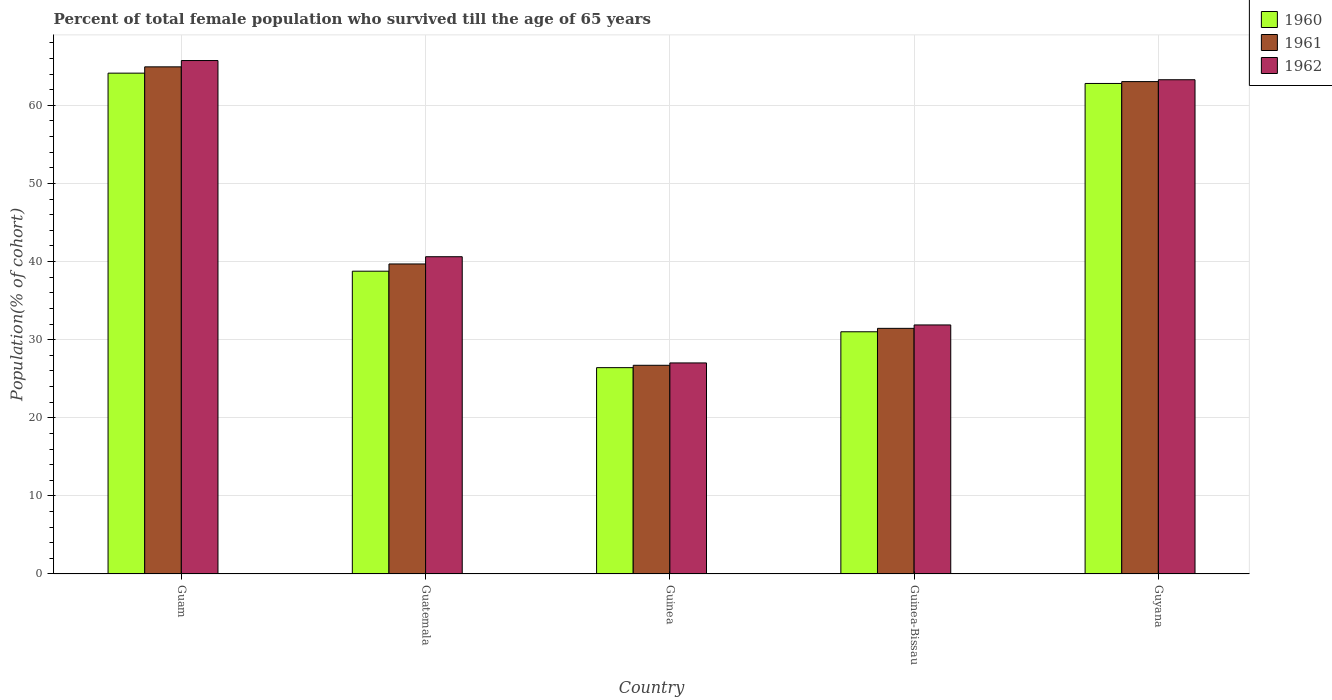How many different coloured bars are there?
Offer a terse response. 3. How many groups of bars are there?
Your answer should be compact. 5. How many bars are there on the 5th tick from the left?
Make the answer very short. 3. What is the label of the 3rd group of bars from the left?
Provide a succinct answer. Guinea. What is the percentage of total female population who survived till the age of 65 years in 1961 in Guam?
Your answer should be compact. 64.93. Across all countries, what is the maximum percentage of total female population who survived till the age of 65 years in 1961?
Your answer should be very brief. 64.93. Across all countries, what is the minimum percentage of total female population who survived till the age of 65 years in 1961?
Offer a terse response. 26.72. In which country was the percentage of total female population who survived till the age of 65 years in 1962 maximum?
Your answer should be very brief. Guam. In which country was the percentage of total female population who survived till the age of 65 years in 1961 minimum?
Provide a succinct answer. Guinea. What is the total percentage of total female population who survived till the age of 65 years in 1962 in the graph?
Your answer should be compact. 228.53. What is the difference between the percentage of total female population who survived till the age of 65 years in 1962 in Guam and that in Guinea?
Offer a very short reply. 38.71. What is the difference between the percentage of total female population who survived till the age of 65 years in 1961 in Guinea-Bissau and the percentage of total female population who survived till the age of 65 years in 1962 in Guam?
Your answer should be very brief. -34.29. What is the average percentage of total female population who survived till the age of 65 years in 1960 per country?
Keep it short and to the point. 44.62. What is the difference between the percentage of total female population who survived till the age of 65 years of/in 1961 and percentage of total female population who survived till the age of 65 years of/in 1962 in Guam?
Ensure brevity in your answer.  -0.81. In how many countries, is the percentage of total female population who survived till the age of 65 years in 1960 greater than 34 %?
Keep it short and to the point. 3. What is the ratio of the percentage of total female population who survived till the age of 65 years in 1960 in Guam to that in Guatemala?
Ensure brevity in your answer.  1.65. Is the percentage of total female population who survived till the age of 65 years in 1961 in Guatemala less than that in Guyana?
Keep it short and to the point. Yes. Is the difference between the percentage of total female population who survived till the age of 65 years in 1961 in Guinea-Bissau and Guyana greater than the difference between the percentage of total female population who survived till the age of 65 years in 1962 in Guinea-Bissau and Guyana?
Your response must be concise. No. What is the difference between the highest and the second highest percentage of total female population who survived till the age of 65 years in 1961?
Give a very brief answer. 25.24. What is the difference between the highest and the lowest percentage of total female population who survived till the age of 65 years in 1962?
Your answer should be very brief. 38.71. In how many countries, is the percentage of total female population who survived till the age of 65 years in 1960 greater than the average percentage of total female population who survived till the age of 65 years in 1960 taken over all countries?
Offer a terse response. 2. Is the sum of the percentage of total female population who survived till the age of 65 years in 1960 in Guam and Guatemala greater than the maximum percentage of total female population who survived till the age of 65 years in 1962 across all countries?
Your answer should be compact. Yes. What does the 1st bar from the left in Guatemala represents?
Make the answer very short. 1960. What does the 1st bar from the right in Guinea represents?
Offer a very short reply. 1962. Is it the case that in every country, the sum of the percentage of total female population who survived till the age of 65 years in 1960 and percentage of total female population who survived till the age of 65 years in 1961 is greater than the percentage of total female population who survived till the age of 65 years in 1962?
Keep it short and to the point. Yes. Are all the bars in the graph horizontal?
Ensure brevity in your answer.  No. Are the values on the major ticks of Y-axis written in scientific E-notation?
Give a very brief answer. No. Does the graph contain any zero values?
Your response must be concise. No. Does the graph contain grids?
Make the answer very short. Yes. How many legend labels are there?
Your answer should be compact. 3. What is the title of the graph?
Your answer should be very brief. Percent of total female population who survived till the age of 65 years. What is the label or title of the Y-axis?
Offer a terse response. Population(% of cohort). What is the Population(% of cohort) of 1960 in Guam?
Provide a short and direct response. 64.12. What is the Population(% of cohort) of 1961 in Guam?
Offer a terse response. 64.93. What is the Population(% of cohort) of 1962 in Guam?
Give a very brief answer. 65.73. What is the Population(% of cohort) in 1960 in Guatemala?
Provide a short and direct response. 38.76. What is the Population(% of cohort) in 1961 in Guatemala?
Ensure brevity in your answer.  39.69. What is the Population(% of cohort) of 1962 in Guatemala?
Keep it short and to the point. 40.62. What is the Population(% of cohort) of 1960 in Guinea?
Ensure brevity in your answer.  26.42. What is the Population(% of cohort) of 1961 in Guinea?
Make the answer very short. 26.72. What is the Population(% of cohort) in 1962 in Guinea?
Make the answer very short. 27.02. What is the Population(% of cohort) of 1960 in Guinea-Bissau?
Provide a short and direct response. 31.01. What is the Population(% of cohort) in 1961 in Guinea-Bissau?
Your answer should be compact. 31.45. What is the Population(% of cohort) of 1962 in Guinea-Bissau?
Your response must be concise. 31.88. What is the Population(% of cohort) in 1960 in Guyana?
Keep it short and to the point. 62.8. What is the Population(% of cohort) in 1961 in Guyana?
Provide a succinct answer. 63.04. What is the Population(% of cohort) of 1962 in Guyana?
Provide a short and direct response. 63.28. Across all countries, what is the maximum Population(% of cohort) of 1960?
Give a very brief answer. 64.12. Across all countries, what is the maximum Population(% of cohort) in 1961?
Provide a succinct answer. 64.93. Across all countries, what is the maximum Population(% of cohort) of 1962?
Make the answer very short. 65.73. Across all countries, what is the minimum Population(% of cohort) in 1960?
Keep it short and to the point. 26.42. Across all countries, what is the minimum Population(% of cohort) in 1961?
Your answer should be compact. 26.72. Across all countries, what is the minimum Population(% of cohort) in 1962?
Ensure brevity in your answer.  27.02. What is the total Population(% of cohort) in 1960 in the graph?
Make the answer very short. 223.1. What is the total Population(% of cohort) in 1961 in the graph?
Offer a terse response. 225.82. What is the total Population(% of cohort) of 1962 in the graph?
Your response must be concise. 228.53. What is the difference between the Population(% of cohort) of 1960 in Guam and that in Guatemala?
Provide a short and direct response. 25.36. What is the difference between the Population(% of cohort) in 1961 in Guam and that in Guatemala?
Make the answer very short. 25.24. What is the difference between the Population(% of cohort) of 1962 in Guam and that in Guatemala?
Offer a very short reply. 25.12. What is the difference between the Population(% of cohort) in 1960 in Guam and that in Guinea?
Your answer should be very brief. 37.7. What is the difference between the Population(% of cohort) in 1961 in Guam and that in Guinea?
Offer a very short reply. 38.21. What is the difference between the Population(% of cohort) of 1962 in Guam and that in Guinea?
Your answer should be very brief. 38.71. What is the difference between the Population(% of cohort) in 1960 in Guam and that in Guinea-Bissau?
Your answer should be very brief. 33.11. What is the difference between the Population(% of cohort) in 1961 in Guam and that in Guinea-Bissau?
Provide a short and direct response. 33.48. What is the difference between the Population(% of cohort) of 1962 in Guam and that in Guinea-Bissau?
Your answer should be very brief. 33.85. What is the difference between the Population(% of cohort) of 1960 in Guam and that in Guyana?
Make the answer very short. 1.32. What is the difference between the Population(% of cohort) in 1961 in Guam and that in Guyana?
Ensure brevity in your answer.  1.89. What is the difference between the Population(% of cohort) in 1962 in Guam and that in Guyana?
Provide a succinct answer. 2.46. What is the difference between the Population(% of cohort) of 1960 in Guatemala and that in Guinea?
Your answer should be very brief. 12.35. What is the difference between the Population(% of cohort) in 1961 in Guatemala and that in Guinea?
Ensure brevity in your answer.  12.97. What is the difference between the Population(% of cohort) in 1962 in Guatemala and that in Guinea?
Give a very brief answer. 13.6. What is the difference between the Population(% of cohort) of 1960 in Guatemala and that in Guinea-Bissau?
Offer a very short reply. 7.76. What is the difference between the Population(% of cohort) in 1961 in Guatemala and that in Guinea-Bissau?
Offer a very short reply. 8.24. What is the difference between the Population(% of cohort) of 1962 in Guatemala and that in Guinea-Bissau?
Provide a short and direct response. 8.73. What is the difference between the Population(% of cohort) of 1960 in Guatemala and that in Guyana?
Your response must be concise. -24.04. What is the difference between the Population(% of cohort) in 1961 in Guatemala and that in Guyana?
Your response must be concise. -23.35. What is the difference between the Population(% of cohort) in 1962 in Guatemala and that in Guyana?
Your response must be concise. -22.66. What is the difference between the Population(% of cohort) of 1960 in Guinea and that in Guinea-Bissau?
Give a very brief answer. -4.59. What is the difference between the Population(% of cohort) in 1961 in Guinea and that in Guinea-Bissau?
Keep it short and to the point. -4.73. What is the difference between the Population(% of cohort) of 1962 in Guinea and that in Guinea-Bissau?
Keep it short and to the point. -4.86. What is the difference between the Population(% of cohort) of 1960 in Guinea and that in Guyana?
Your response must be concise. -36.38. What is the difference between the Population(% of cohort) in 1961 in Guinea and that in Guyana?
Provide a succinct answer. -36.32. What is the difference between the Population(% of cohort) of 1962 in Guinea and that in Guyana?
Offer a terse response. -36.26. What is the difference between the Population(% of cohort) in 1960 in Guinea-Bissau and that in Guyana?
Provide a succinct answer. -31.79. What is the difference between the Population(% of cohort) in 1961 in Guinea-Bissau and that in Guyana?
Make the answer very short. -31.59. What is the difference between the Population(% of cohort) in 1962 in Guinea-Bissau and that in Guyana?
Offer a very short reply. -31.39. What is the difference between the Population(% of cohort) in 1960 in Guam and the Population(% of cohort) in 1961 in Guatemala?
Your response must be concise. 24.43. What is the difference between the Population(% of cohort) in 1960 in Guam and the Population(% of cohort) in 1962 in Guatemala?
Offer a terse response. 23.5. What is the difference between the Population(% of cohort) of 1961 in Guam and the Population(% of cohort) of 1962 in Guatemala?
Offer a very short reply. 24.31. What is the difference between the Population(% of cohort) of 1960 in Guam and the Population(% of cohort) of 1961 in Guinea?
Offer a very short reply. 37.4. What is the difference between the Population(% of cohort) of 1960 in Guam and the Population(% of cohort) of 1962 in Guinea?
Offer a very short reply. 37.1. What is the difference between the Population(% of cohort) in 1961 in Guam and the Population(% of cohort) in 1962 in Guinea?
Offer a terse response. 37.91. What is the difference between the Population(% of cohort) in 1960 in Guam and the Population(% of cohort) in 1961 in Guinea-Bissau?
Give a very brief answer. 32.67. What is the difference between the Population(% of cohort) in 1960 in Guam and the Population(% of cohort) in 1962 in Guinea-Bissau?
Ensure brevity in your answer.  32.24. What is the difference between the Population(% of cohort) of 1961 in Guam and the Population(% of cohort) of 1962 in Guinea-Bissau?
Your answer should be very brief. 33.04. What is the difference between the Population(% of cohort) in 1960 in Guam and the Population(% of cohort) in 1961 in Guyana?
Offer a very short reply. 1.08. What is the difference between the Population(% of cohort) of 1960 in Guam and the Population(% of cohort) of 1962 in Guyana?
Offer a very short reply. 0.84. What is the difference between the Population(% of cohort) of 1961 in Guam and the Population(% of cohort) of 1962 in Guyana?
Offer a terse response. 1.65. What is the difference between the Population(% of cohort) of 1960 in Guatemala and the Population(% of cohort) of 1961 in Guinea?
Your answer should be compact. 12.05. What is the difference between the Population(% of cohort) of 1960 in Guatemala and the Population(% of cohort) of 1962 in Guinea?
Keep it short and to the point. 11.74. What is the difference between the Population(% of cohort) in 1961 in Guatemala and the Population(% of cohort) in 1962 in Guinea?
Provide a succinct answer. 12.67. What is the difference between the Population(% of cohort) of 1960 in Guatemala and the Population(% of cohort) of 1961 in Guinea-Bissau?
Make the answer very short. 7.32. What is the difference between the Population(% of cohort) of 1960 in Guatemala and the Population(% of cohort) of 1962 in Guinea-Bissau?
Keep it short and to the point. 6.88. What is the difference between the Population(% of cohort) in 1961 in Guatemala and the Population(% of cohort) in 1962 in Guinea-Bissau?
Your response must be concise. 7.81. What is the difference between the Population(% of cohort) of 1960 in Guatemala and the Population(% of cohort) of 1961 in Guyana?
Your response must be concise. -24.27. What is the difference between the Population(% of cohort) in 1960 in Guatemala and the Population(% of cohort) in 1962 in Guyana?
Provide a succinct answer. -24.51. What is the difference between the Population(% of cohort) of 1961 in Guatemala and the Population(% of cohort) of 1962 in Guyana?
Your response must be concise. -23.59. What is the difference between the Population(% of cohort) of 1960 in Guinea and the Population(% of cohort) of 1961 in Guinea-Bissau?
Provide a succinct answer. -5.03. What is the difference between the Population(% of cohort) in 1960 in Guinea and the Population(% of cohort) in 1962 in Guinea-Bissau?
Make the answer very short. -5.47. What is the difference between the Population(% of cohort) of 1961 in Guinea and the Population(% of cohort) of 1962 in Guinea-Bissau?
Offer a terse response. -5.17. What is the difference between the Population(% of cohort) of 1960 in Guinea and the Population(% of cohort) of 1961 in Guyana?
Your response must be concise. -36.62. What is the difference between the Population(% of cohort) of 1960 in Guinea and the Population(% of cohort) of 1962 in Guyana?
Offer a very short reply. -36.86. What is the difference between the Population(% of cohort) of 1961 in Guinea and the Population(% of cohort) of 1962 in Guyana?
Your answer should be very brief. -36.56. What is the difference between the Population(% of cohort) in 1960 in Guinea-Bissau and the Population(% of cohort) in 1961 in Guyana?
Offer a terse response. -32.03. What is the difference between the Population(% of cohort) in 1960 in Guinea-Bissau and the Population(% of cohort) in 1962 in Guyana?
Your response must be concise. -32.27. What is the difference between the Population(% of cohort) in 1961 in Guinea-Bissau and the Population(% of cohort) in 1962 in Guyana?
Offer a very short reply. -31.83. What is the average Population(% of cohort) of 1960 per country?
Ensure brevity in your answer.  44.62. What is the average Population(% of cohort) of 1961 per country?
Your answer should be compact. 45.16. What is the average Population(% of cohort) of 1962 per country?
Make the answer very short. 45.71. What is the difference between the Population(% of cohort) in 1960 and Population(% of cohort) in 1961 in Guam?
Make the answer very short. -0.81. What is the difference between the Population(% of cohort) in 1960 and Population(% of cohort) in 1962 in Guam?
Provide a short and direct response. -1.61. What is the difference between the Population(% of cohort) of 1961 and Population(% of cohort) of 1962 in Guam?
Your response must be concise. -0.81. What is the difference between the Population(% of cohort) of 1960 and Population(% of cohort) of 1961 in Guatemala?
Your response must be concise. -0.93. What is the difference between the Population(% of cohort) in 1960 and Population(% of cohort) in 1962 in Guatemala?
Your answer should be very brief. -1.85. What is the difference between the Population(% of cohort) of 1961 and Population(% of cohort) of 1962 in Guatemala?
Your answer should be very brief. -0.93. What is the difference between the Population(% of cohort) in 1960 and Population(% of cohort) in 1961 in Guinea?
Give a very brief answer. -0.3. What is the difference between the Population(% of cohort) of 1960 and Population(% of cohort) of 1962 in Guinea?
Give a very brief answer. -0.6. What is the difference between the Population(% of cohort) of 1961 and Population(% of cohort) of 1962 in Guinea?
Your response must be concise. -0.3. What is the difference between the Population(% of cohort) in 1960 and Population(% of cohort) in 1961 in Guinea-Bissau?
Provide a short and direct response. -0.44. What is the difference between the Population(% of cohort) of 1960 and Population(% of cohort) of 1962 in Guinea-Bissau?
Give a very brief answer. -0.88. What is the difference between the Population(% of cohort) in 1961 and Population(% of cohort) in 1962 in Guinea-Bissau?
Keep it short and to the point. -0.44. What is the difference between the Population(% of cohort) in 1960 and Population(% of cohort) in 1961 in Guyana?
Ensure brevity in your answer.  -0.24. What is the difference between the Population(% of cohort) in 1960 and Population(% of cohort) in 1962 in Guyana?
Provide a succinct answer. -0.48. What is the difference between the Population(% of cohort) in 1961 and Population(% of cohort) in 1962 in Guyana?
Your response must be concise. -0.24. What is the ratio of the Population(% of cohort) of 1960 in Guam to that in Guatemala?
Ensure brevity in your answer.  1.65. What is the ratio of the Population(% of cohort) in 1961 in Guam to that in Guatemala?
Give a very brief answer. 1.64. What is the ratio of the Population(% of cohort) in 1962 in Guam to that in Guatemala?
Offer a terse response. 1.62. What is the ratio of the Population(% of cohort) of 1960 in Guam to that in Guinea?
Offer a terse response. 2.43. What is the ratio of the Population(% of cohort) in 1961 in Guam to that in Guinea?
Offer a terse response. 2.43. What is the ratio of the Population(% of cohort) in 1962 in Guam to that in Guinea?
Make the answer very short. 2.43. What is the ratio of the Population(% of cohort) of 1960 in Guam to that in Guinea-Bissau?
Ensure brevity in your answer.  2.07. What is the ratio of the Population(% of cohort) of 1961 in Guam to that in Guinea-Bissau?
Provide a succinct answer. 2.06. What is the ratio of the Population(% of cohort) of 1962 in Guam to that in Guinea-Bissau?
Offer a terse response. 2.06. What is the ratio of the Population(% of cohort) in 1962 in Guam to that in Guyana?
Make the answer very short. 1.04. What is the ratio of the Population(% of cohort) of 1960 in Guatemala to that in Guinea?
Your answer should be compact. 1.47. What is the ratio of the Population(% of cohort) of 1961 in Guatemala to that in Guinea?
Provide a succinct answer. 1.49. What is the ratio of the Population(% of cohort) in 1962 in Guatemala to that in Guinea?
Offer a very short reply. 1.5. What is the ratio of the Population(% of cohort) of 1960 in Guatemala to that in Guinea-Bissau?
Ensure brevity in your answer.  1.25. What is the ratio of the Population(% of cohort) in 1961 in Guatemala to that in Guinea-Bissau?
Your response must be concise. 1.26. What is the ratio of the Population(% of cohort) in 1962 in Guatemala to that in Guinea-Bissau?
Your response must be concise. 1.27. What is the ratio of the Population(% of cohort) in 1960 in Guatemala to that in Guyana?
Make the answer very short. 0.62. What is the ratio of the Population(% of cohort) in 1961 in Guatemala to that in Guyana?
Give a very brief answer. 0.63. What is the ratio of the Population(% of cohort) of 1962 in Guatemala to that in Guyana?
Your answer should be compact. 0.64. What is the ratio of the Population(% of cohort) of 1960 in Guinea to that in Guinea-Bissau?
Make the answer very short. 0.85. What is the ratio of the Population(% of cohort) of 1961 in Guinea to that in Guinea-Bissau?
Make the answer very short. 0.85. What is the ratio of the Population(% of cohort) in 1962 in Guinea to that in Guinea-Bissau?
Offer a terse response. 0.85. What is the ratio of the Population(% of cohort) in 1960 in Guinea to that in Guyana?
Make the answer very short. 0.42. What is the ratio of the Population(% of cohort) in 1961 in Guinea to that in Guyana?
Keep it short and to the point. 0.42. What is the ratio of the Population(% of cohort) in 1962 in Guinea to that in Guyana?
Offer a terse response. 0.43. What is the ratio of the Population(% of cohort) in 1960 in Guinea-Bissau to that in Guyana?
Ensure brevity in your answer.  0.49. What is the ratio of the Population(% of cohort) in 1961 in Guinea-Bissau to that in Guyana?
Offer a terse response. 0.5. What is the ratio of the Population(% of cohort) in 1962 in Guinea-Bissau to that in Guyana?
Your answer should be compact. 0.5. What is the difference between the highest and the second highest Population(% of cohort) in 1960?
Your answer should be compact. 1.32. What is the difference between the highest and the second highest Population(% of cohort) in 1961?
Provide a succinct answer. 1.89. What is the difference between the highest and the second highest Population(% of cohort) of 1962?
Offer a very short reply. 2.46. What is the difference between the highest and the lowest Population(% of cohort) in 1960?
Give a very brief answer. 37.7. What is the difference between the highest and the lowest Population(% of cohort) of 1961?
Ensure brevity in your answer.  38.21. What is the difference between the highest and the lowest Population(% of cohort) in 1962?
Ensure brevity in your answer.  38.71. 